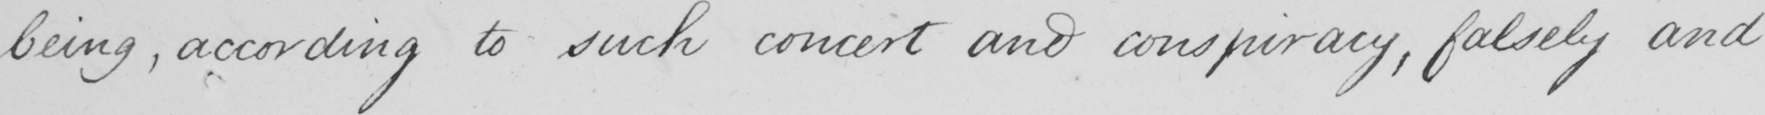Please transcribe the handwritten text in this image. being , according to such conceit and conspiracy , falsely and 